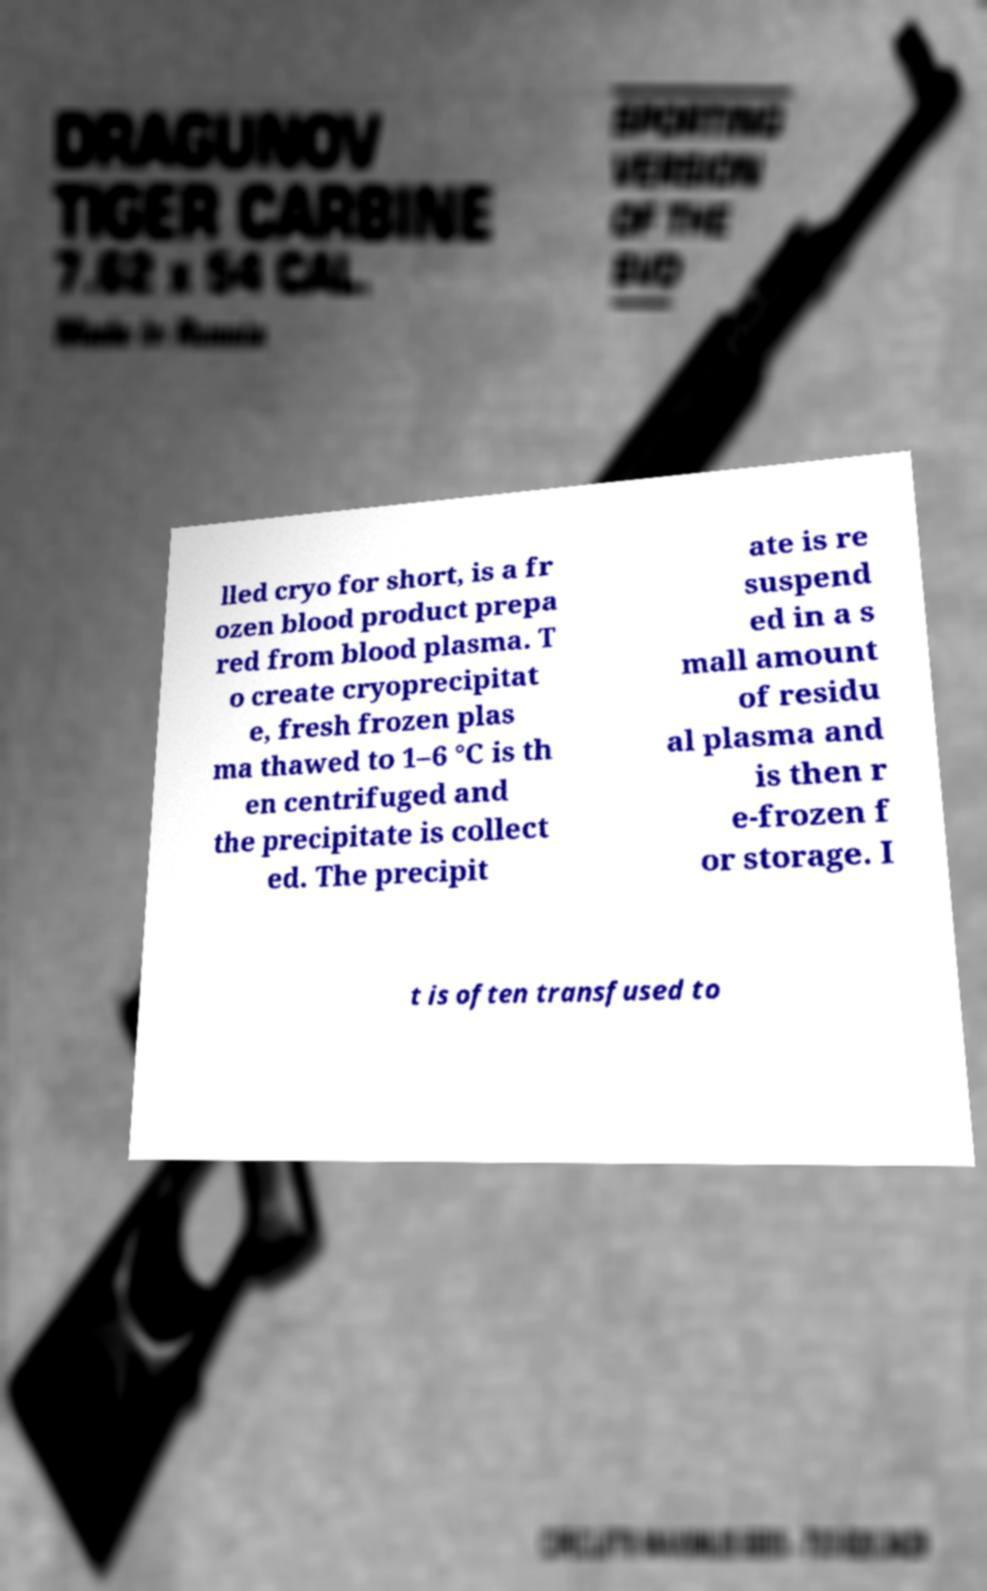What messages or text are displayed in this image? I need them in a readable, typed format. lled cryo for short, is a fr ozen blood product prepa red from blood plasma. T o create cryoprecipitat e, fresh frozen plas ma thawed to 1–6 °C is th en centrifuged and the precipitate is collect ed. The precipit ate is re suspend ed in a s mall amount of residu al plasma and is then r e-frozen f or storage. I t is often transfused to 